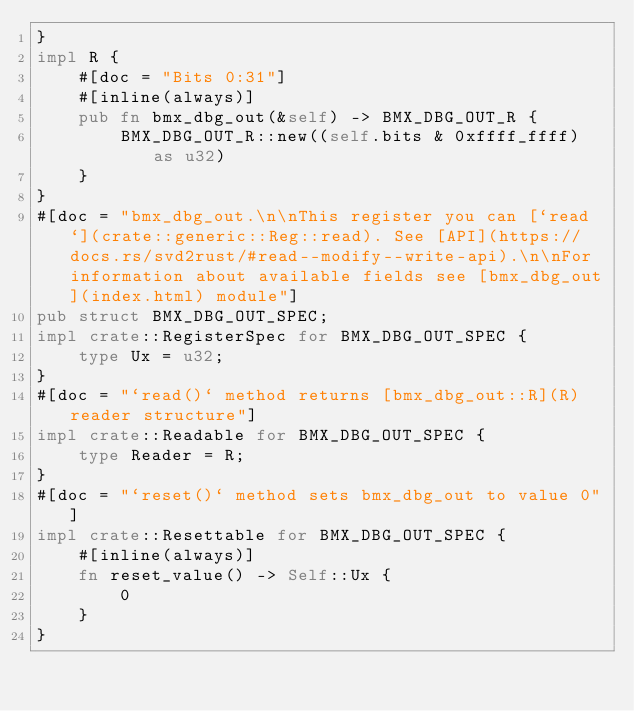Convert code to text. <code><loc_0><loc_0><loc_500><loc_500><_Rust_>}
impl R {
    #[doc = "Bits 0:31"]
    #[inline(always)]
    pub fn bmx_dbg_out(&self) -> BMX_DBG_OUT_R {
        BMX_DBG_OUT_R::new((self.bits & 0xffff_ffff) as u32)
    }
}
#[doc = "bmx_dbg_out.\n\nThis register you can [`read`](crate::generic::Reg::read). See [API](https://docs.rs/svd2rust/#read--modify--write-api).\n\nFor information about available fields see [bmx_dbg_out](index.html) module"]
pub struct BMX_DBG_OUT_SPEC;
impl crate::RegisterSpec for BMX_DBG_OUT_SPEC {
    type Ux = u32;
}
#[doc = "`read()` method returns [bmx_dbg_out::R](R) reader structure"]
impl crate::Readable for BMX_DBG_OUT_SPEC {
    type Reader = R;
}
#[doc = "`reset()` method sets bmx_dbg_out to value 0"]
impl crate::Resettable for BMX_DBG_OUT_SPEC {
    #[inline(always)]
    fn reset_value() -> Self::Ux {
        0
    }
}
</code> 